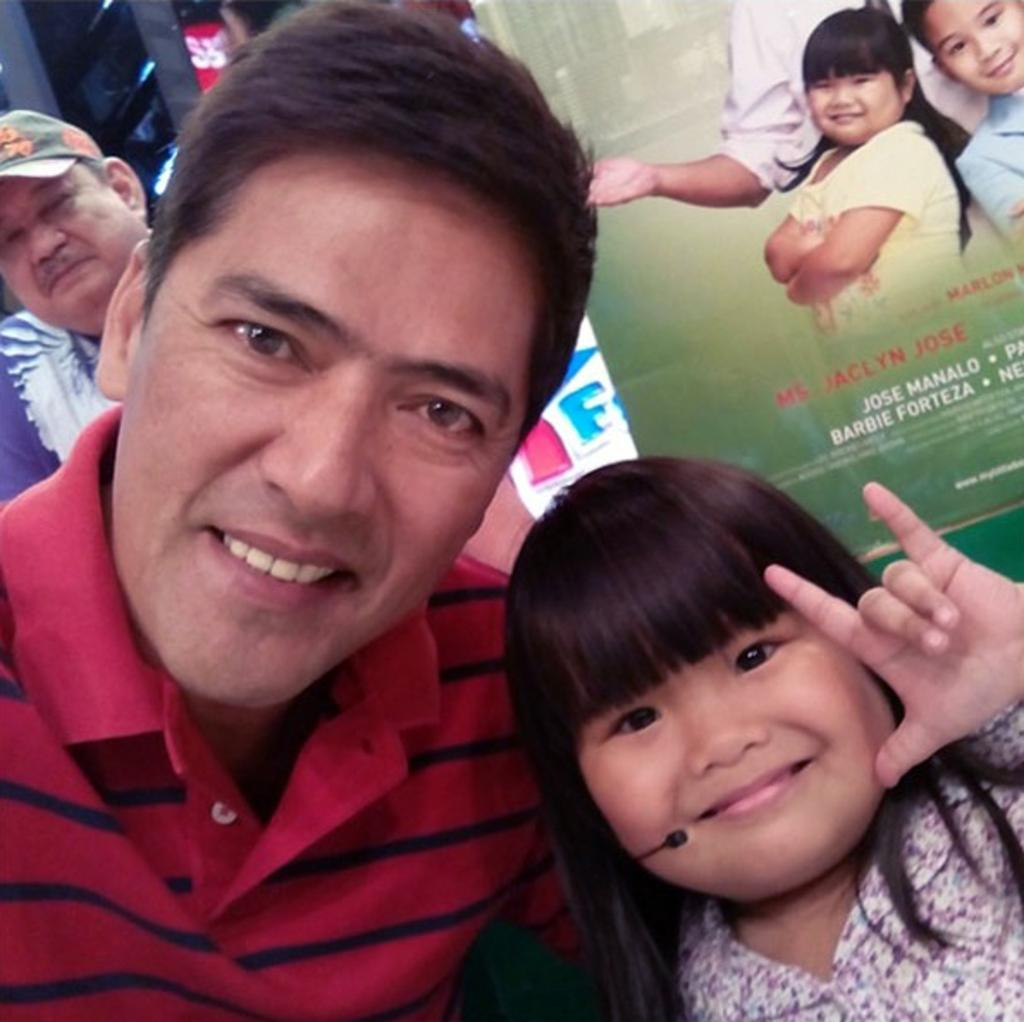Who is the main subject in the center of the image? There is a girl in the center of the image. What can be seen in the background of the image? There is an advertisement and another person in the background of the image. What type of crate is being used by the girl in the image? There is no crate present in the image. What tool is the girl using to fix the wrench in the image? There is no wrench or tool present in the image. 